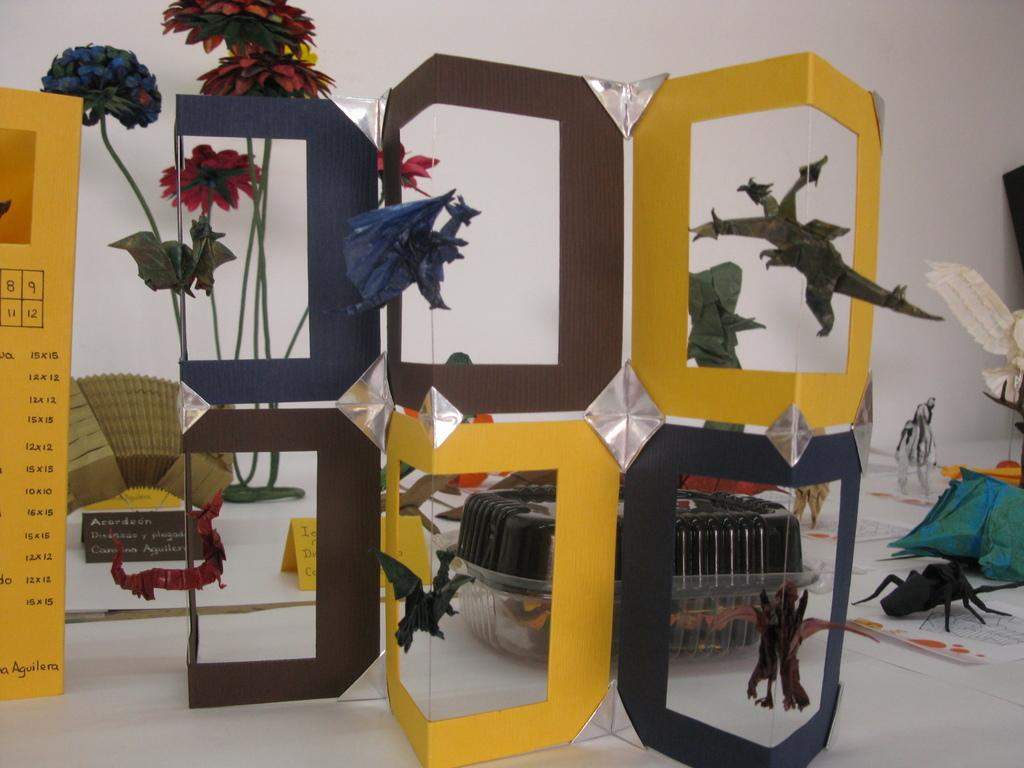What type of art can be seen in the image? There is art made with papers in the image. What other elements are present in the image besides the paper art? There are flowers in the image. How many women are present in the image? There is no mention of women in the image, as it only features paper art and flowers. 